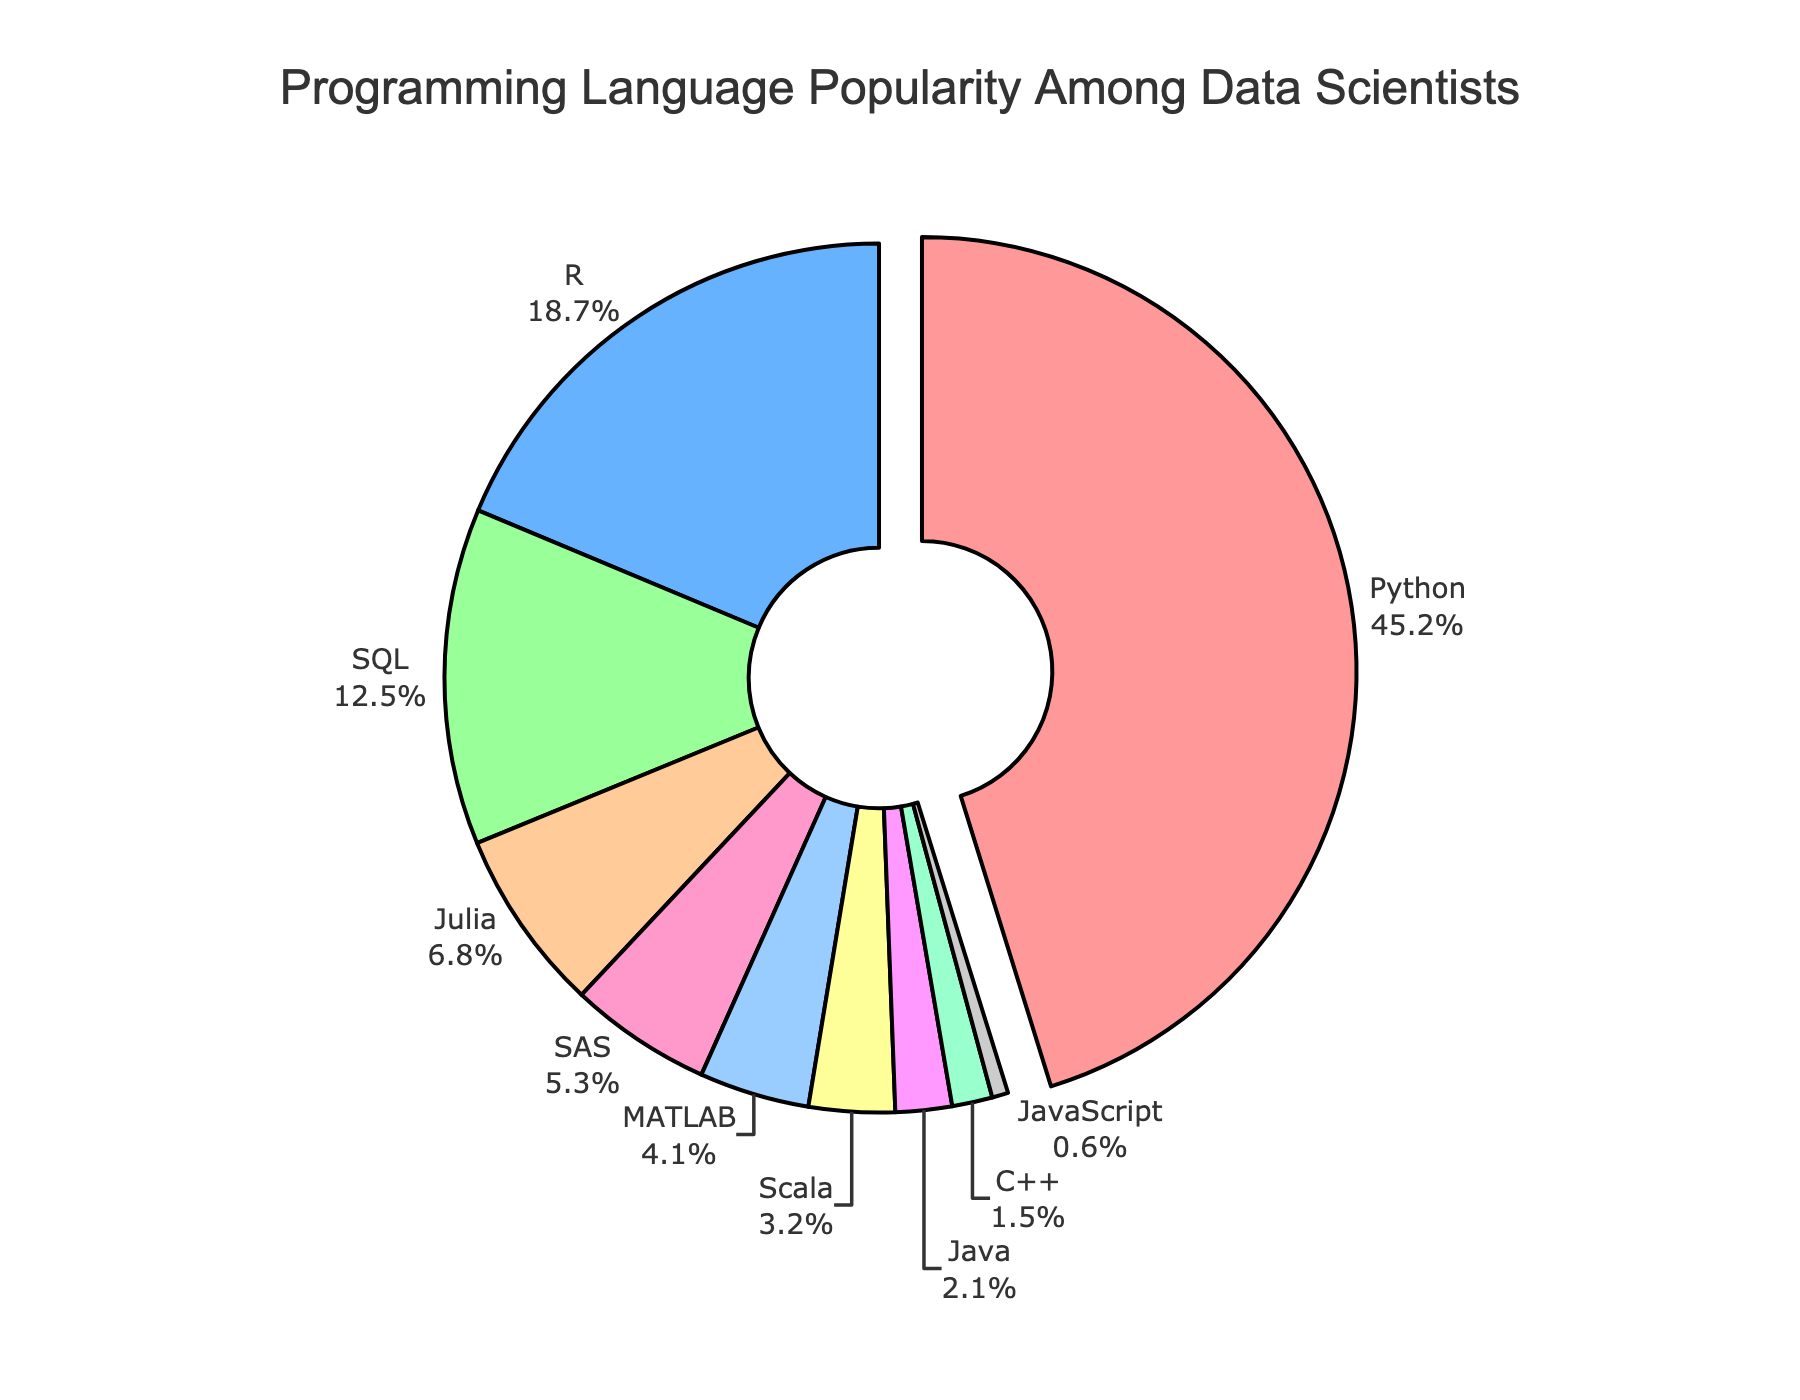What is the most popular programming language among data scientists? The figure shows a pie chart where the segment with the largest percentage is highlighted and indicates Python with 45.2%.
Answer: Python How do the combined percentages of Python and R compare to the combined percentages of SQL and Julia? Adding the percentages, Python and R jointly have 45.2% + 18.7% = 63.9%, while SQL and Julia combined have 12.5% + 6.8% = 19.3%.
Answer: 63.9% vs 19.3% Which languages together make up more than 50% of the total? Adding the shares until the sum exceeds 50%, Python (45.2%) and R (18.7%) combined make 63.9%, which is more than 50%.
Answer: Python and R What is the percentage difference between the least popular and the most popular programming languages? The most popular language is Python with 45.2%, and the least popular is JavaScript with 0.6%. The difference is 45.2% - 0.6% = 44.6%.
Answer: 44.6% How many languages have a popularity of less than 5%? From the pie chart, the languages under 5% are MATLAB (4.1%), Scala (3.2%), Java (2.1%), C++ (1.5%), and JavaScript (0.6%).
Answer: 5 languages By how much does Python's popularity exceed the combined popularity of SAS and MATLAB? Python has a 45.2% share. SAS and MATLAB together have 5.3% + 4.1% = 9.4%. The excess is 45.2% - 9.4% = 35.8%.
Answer: 35.8% What color represents the programming language with the smallest share? The segment with the smallest share, JavaScript (0.6%), is colored grey.
Answer: Grey If SQL, Julia, SAS, and MATLAB are grouped, what is their combined percentage? Summing these individual slice percentages, SQL (12.5%) + Julia (6.8%) + SAS (5.3%) + MATLAB (4.1%) results in 28.7%.
Answer: 28.7% What is the percentage difference between SQL and Java? SQL has a percentage share of 12.5%, while Java has 2.1%. The difference is 12.5% - 2.1% = 10.4%.
Answer: 10.4% 